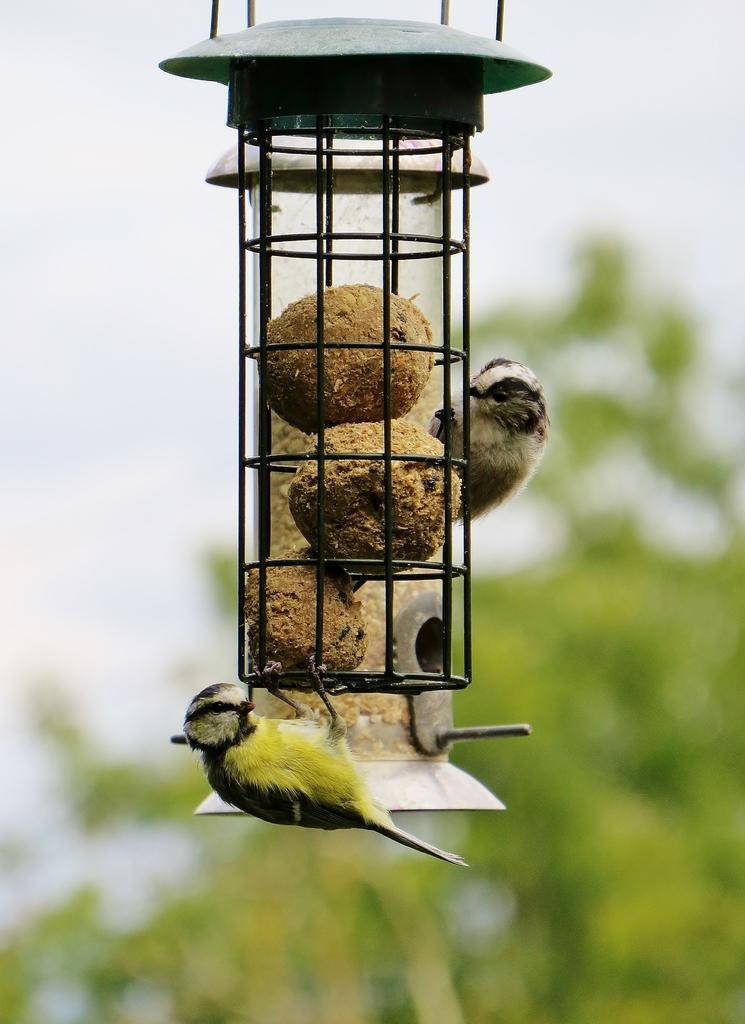How many birds are present in the image? There are two birds in the image. What are the birds doing in the image? The birds are holding an object. What is inside the object that the birds are holding? The object contains food items. What can be seen in the background of the image? There is a tree in the background of the image. What type of society is depicted in the image? There is no society depicted in the image; it features two birds holding an object with food items. What kind of voyage are the birds embarking on in the image? There is no voyage depicted in the image; the birds are simply holding an object with food items. 